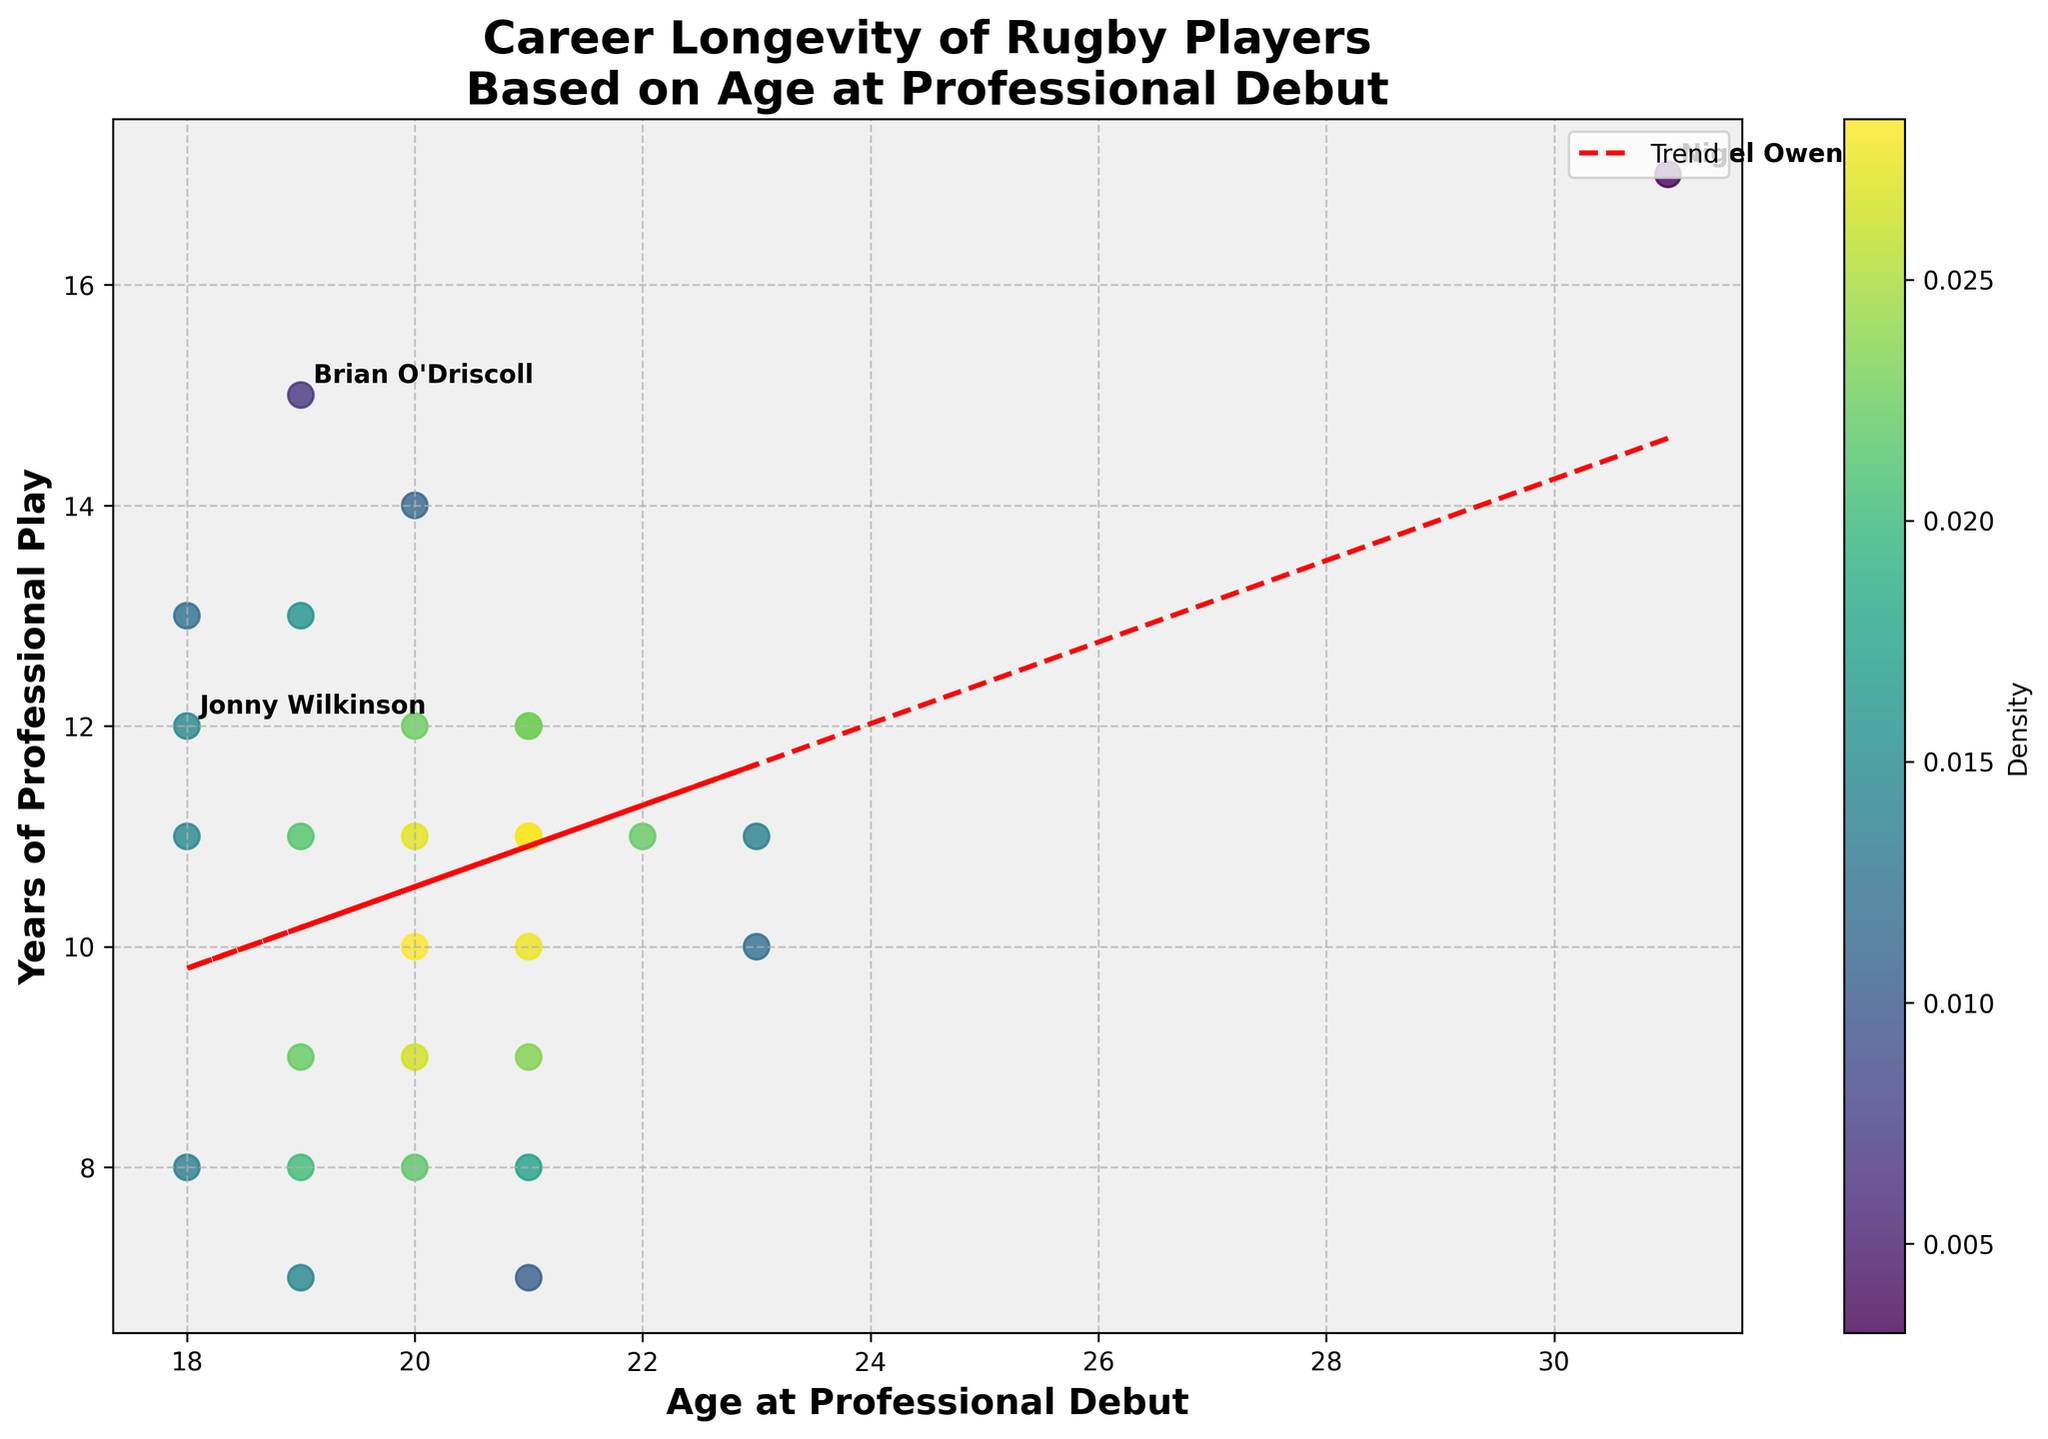What's the title of the figure? The title of the figure is prominently displayed at the top, usually in bold and larger font.
Answer: Career Longevity of Rugby Players Based on Age at Professional Debut What are the axis labels? The axis labels are present along the horizontal and vertical axes, describing the variables being plotted. The horizontal axis is labeled 'Age at Professional Debut', and the vertical axis is labeled 'Years of Professional Play'.
Answer: Age at Professional Debut, Years of Professional Play What color represents the highest density of data points? The figure uses a color gradient from lighter to darker shades representing density. In this plot, 'viridis' colormap is used, where yellow represents the highest density.
Answer: Yellow How does the trend line relate to the scatter points? By examining the trend line plotted on the scatter points, you can see whether the general trend of the points is increasing or decreasing. The red dashed line indicates a general trend where career longevity appears to slightly decrease with increasing age at debut.
Answer: Slightly decreases Which player has the most extended career despite starting late? The names of special cases such as late starters with long careers are annotated directly on the plot. Nigel Owens, who started at 31, had a 17-year long career.
Answer: Nigel Owens What patterns do you observe about the relationship between age at debut and career longevity? Generally, the scatter points and trend line indicate the relationship. Players who start younger (around 19-21) typically have a longer career than those who start at later ages. The scatter plot's density coloring also shows higher concentrations of longer careers for younger debut ages.
Answer: Younger start, longer career How many years did Richie McCaw play professionally, and at what age did he debut? Specific players like Richie McCaw are part of the labeled data, and their points can be identified on the scatter plot. By looking at his labeled point, Richie McCaw debuted at age 20 and had a 14-year career.
Answer: 14 years, age 20 Did any players who debuted at age 18 have a career longer than 10 years? If yes, how many? By looking at the scatter points at age 18 on the horizontal axis and checking their vertical position, you can identify the career length. There are three players who started at age 18 with careers longer than 10 years: Jonny Wilkinson (12), Sonny Bill Williams (11), and George North (13).
Answer: Yes, three Comparing two players with long careers: How many years did Brian O'Driscoll and Kieran Read play, and at what ages did they debut? Check the annotated points and scatter positions for Brian O'Driscoll and Kieran Read. Brian O'Driscoll debuted at age 19 and played for 15 years, while Kieran Read debuted at age 22 and played for 11 years.
Answer: Brian O'Driscoll: 15 years, age 19; Kieran Read: 11 years, age 22 